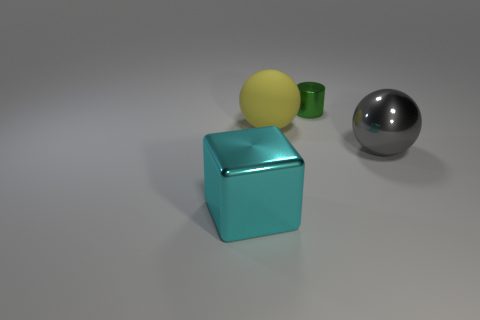Is there anything else that has the same material as the small cylinder?
Offer a terse response. Yes. What is the size of the thing that is in front of the metal object that is on the right side of the tiny thing?
Offer a terse response. Large. What is the size of the object on the left side of the big ball that is to the left of the ball in front of the yellow sphere?
Provide a short and direct response. Large. Is the shape of the yellow thing on the left side of the green shiny object the same as the big shiny thing that is right of the cyan metal block?
Offer a very short reply. Yes. Does the metal object that is behind the matte thing have the same size as the rubber sphere?
Your response must be concise. No. Is the object that is to the right of the small cylinder made of the same material as the object that is behind the yellow sphere?
Keep it short and to the point. Yes. Is there a gray object of the same size as the metal sphere?
Keep it short and to the point. No. What is the shape of the large yellow object that is behind the big metal thing that is to the right of the big shiny thing that is in front of the large gray ball?
Provide a short and direct response. Sphere. Is the number of green metal things left of the small green metallic object greater than the number of large purple matte cylinders?
Your response must be concise. No. Is there a small green metal object that has the same shape as the yellow matte thing?
Make the answer very short. No. 